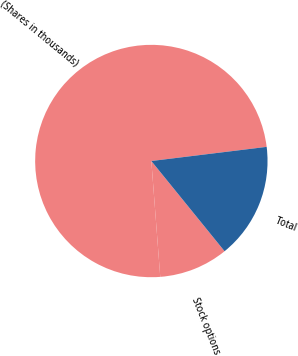Convert chart to OTSL. <chart><loc_0><loc_0><loc_500><loc_500><pie_chart><fcel>(Shares in thousands)<fcel>Stock options<fcel>Total<nl><fcel>74.27%<fcel>9.63%<fcel>16.09%<nl></chart> 